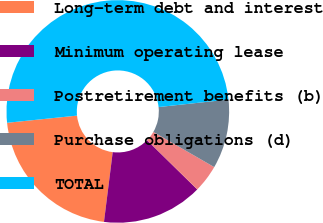Convert chart to OTSL. <chart><loc_0><loc_0><loc_500><loc_500><pie_chart><fcel>Long-term debt and interest<fcel>Minimum operating lease<fcel>Postretirement benefits (b)<fcel>Purchase obligations (d)<fcel>TOTAL<nl><fcel>21.39%<fcel>14.63%<fcel>4.02%<fcel>10.04%<fcel>49.92%<nl></chart> 